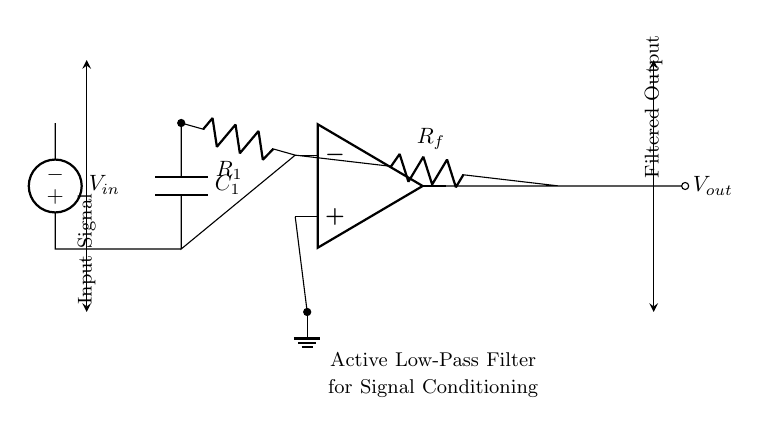What type of filter is represented in the circuit? The circuit diagram depicts an "Active Low-Pass Filter," which is specifically designed to allow low-frequency signals to pass while attenuating higher frequencies. This is indicated by the label provided in the circuit diagram.
Answer: Active Low-Pass Filter What is the role of the capacitor in this circuit? The capacitor, labeled C1, is used to store and release electrical energy, aiding in the filtering of higher frequency signals. It works in conjunction with the resistors to define the cutoff frequency, contributing to the low-pass characteristics.
Answer: Signal filtering How many resistors are present in the circuit? There are two resistors shown in the circuit, labeled R1 and Rf. Each resistor plays a crucial role in determining the gain and response of the active filter.
Answer: Two What is the function of the operational amplifier in this design? The operational amplifier (op amp) amplifies the input signal and plays a central role in the functioning of the active filter. It allows for the high gain necessary for better signal conditioning and is integral to achieving the desired response characteristics.
Answer: Amplification What is the significance of the input voltage source in the circuit? The input voltage source, labeled Vin, provides the original signal that will undergo conditioning through the filter process. Its value is essential as it determines the signal levels that the entire circuit will process and filter.
Answer: Signal input What determines the cutoff frequency of this low-pass filter? The cutoff frequency is determined by the values of resistor R1 and capacitor C1. The formula for the cutoff frequency, which is \( f_c = \frac{1}{2\pi R_1 C_1} \), indicates that both the resistance and capacitance values are crucial for the filter's operation.
Answer: R1 and C1 values Where is the output of the filter taken from in the circuit? The output, labeled Vout, is taken from the output terminal of the operational amplifier, indicating the filtered signal that has passed through the active low-pass filter's circuitry. This point is crucial as it provides the processed signal.
Answer: From the op amp output 